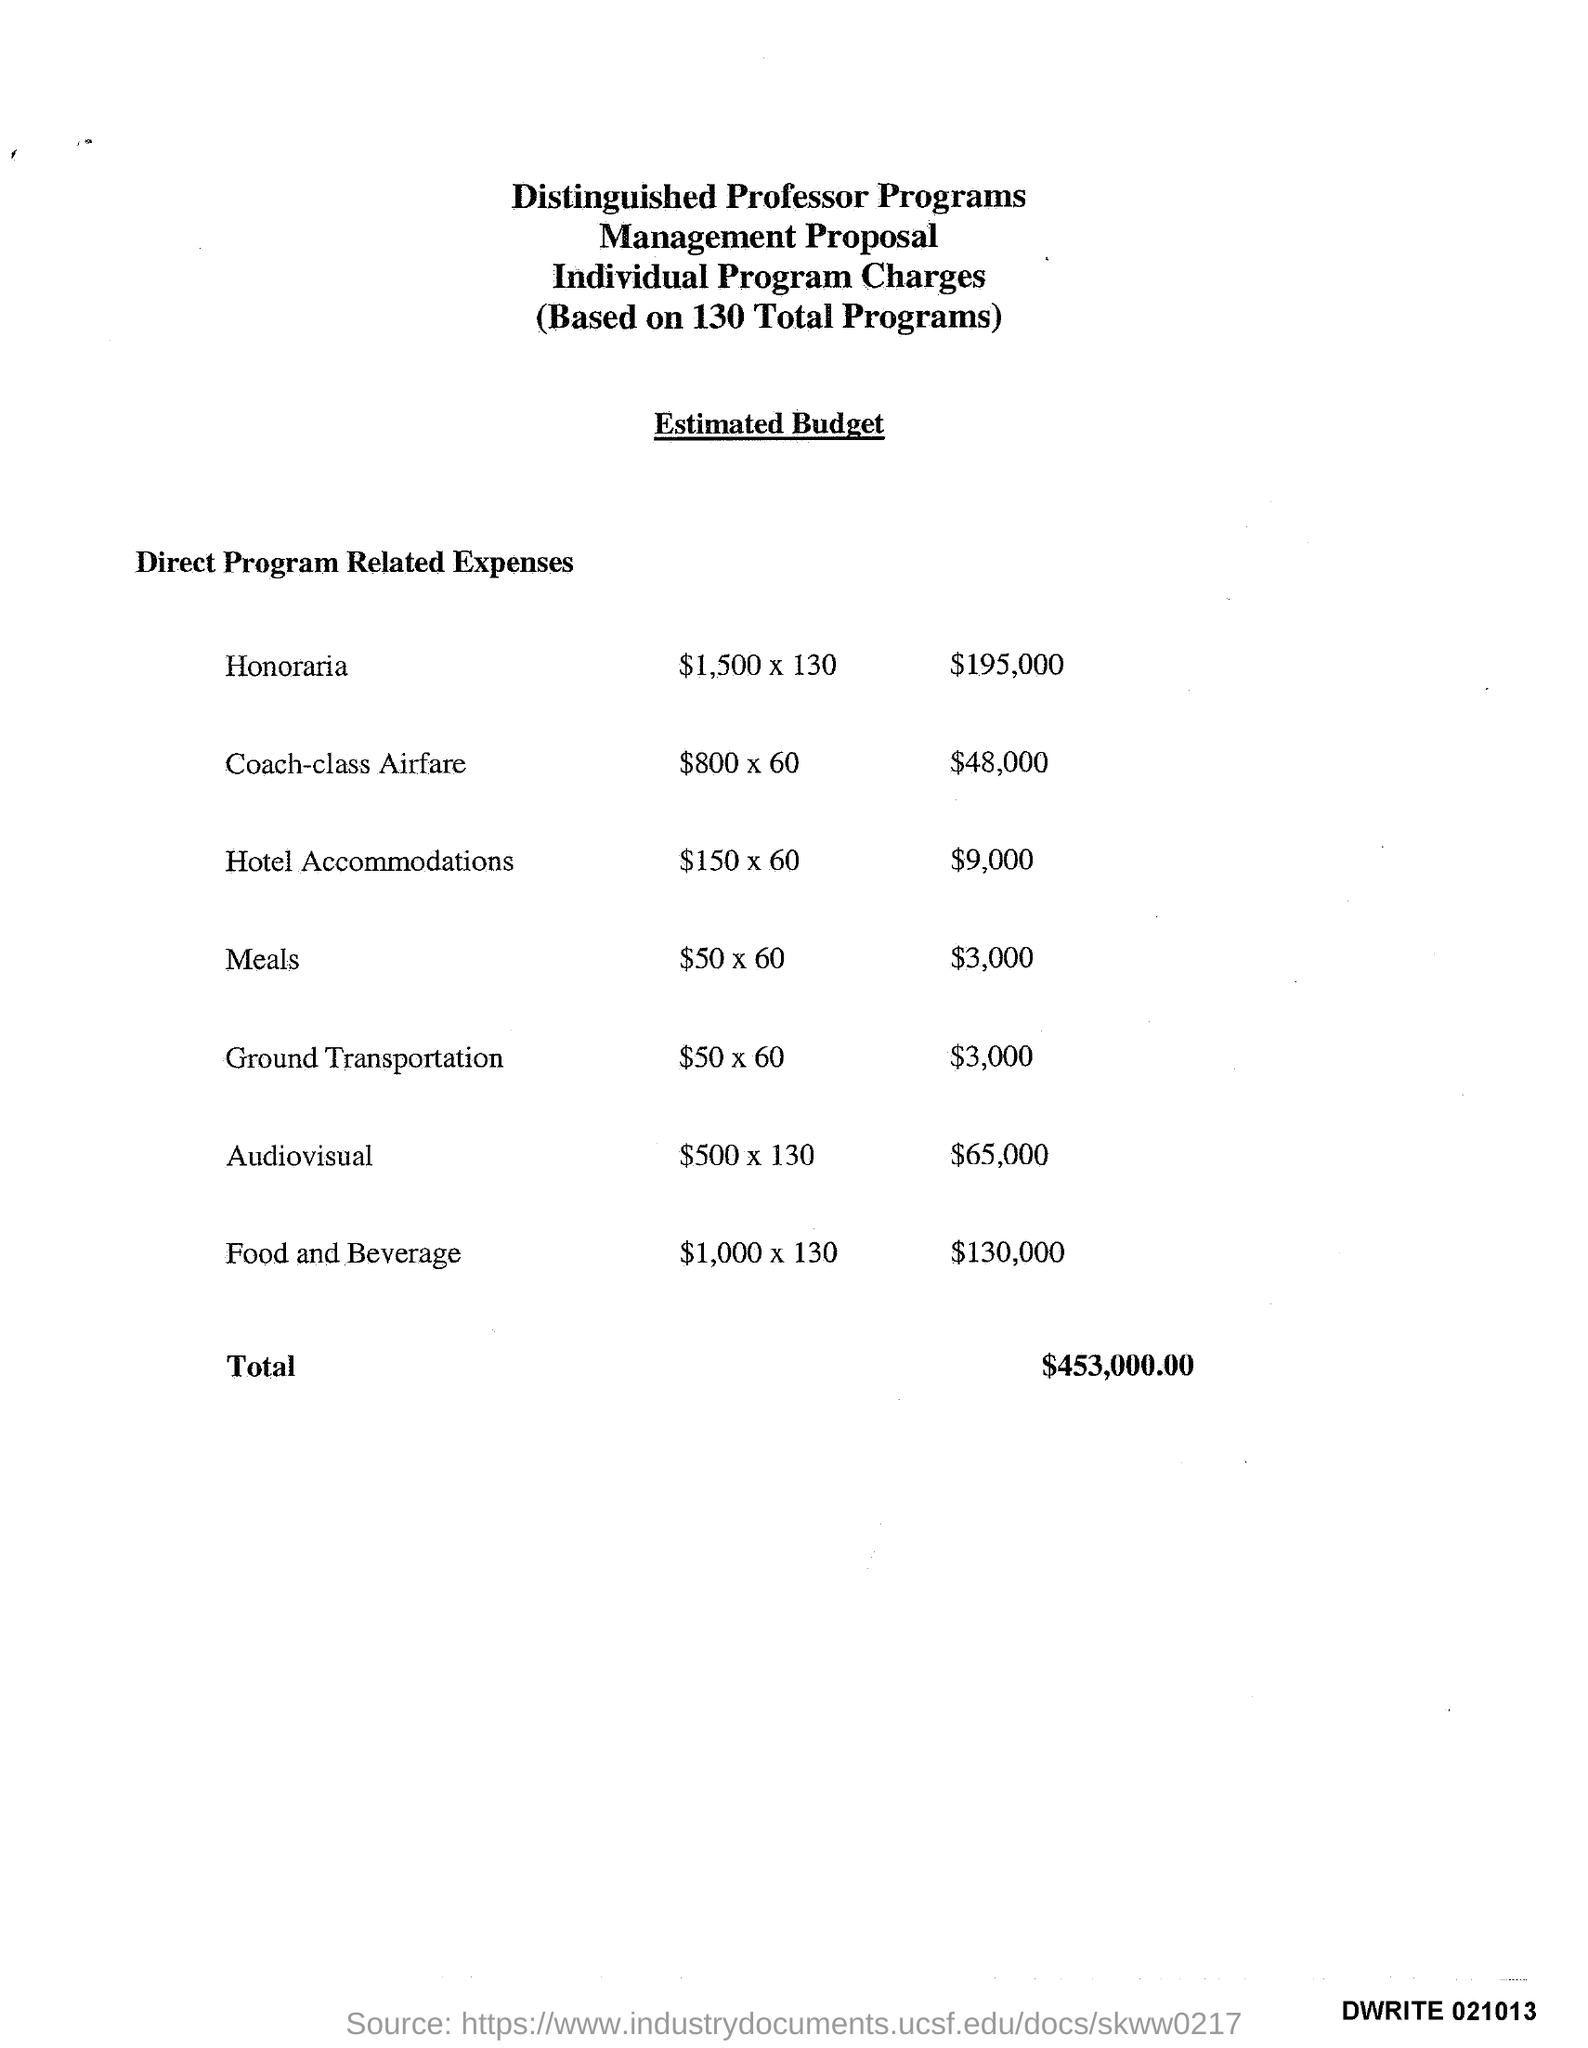what is the name of the program which spent $195,000 ?
 Honoraria 